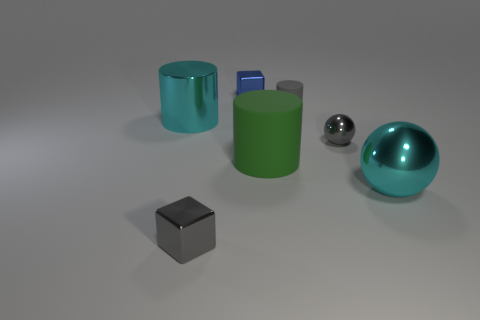Add 2 metal balls. How many objects exist? 9 Subtract all cylinders. How many objects are left? 4 Add 6 large purple rubber balls. How many large purple rubber balls exist? 6 Subtract 0 brown spheres. How many objects are left? 7 Subtract all gray shiny cylinders. Subtract all small gray metal objects. How many objects are left? 5 Add 7 green matte cylinders. How many green matte cylinders are left? 8 